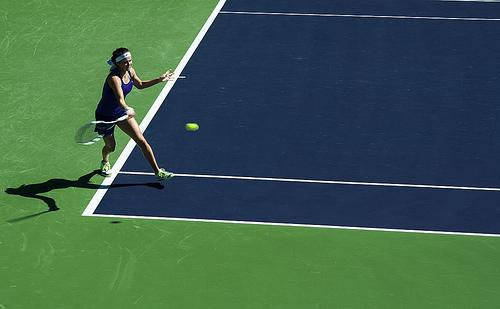In a few words, describe the main scene depicted in the image. A woman in blue tennis attire hitting a flying yellow tennis ball. Provide a basic summary of the situation shown in the image. A woman dressed in tennis gear is in motion as she prepares to hit a yellow ball during a tennis match. Explain the scene of the image in your own words. A lady wearing a blue tennis outfit is playing a game and trying to hit an airborne yellow tennis ball with her racket. Give a brief overview of the main elements in the photograph. A female athlete in blue tennis gear is swinging at a soaring yellow tennis ball in the middle of a match. In one sentence, describe what is happening in the image. The picture shows a woman tennis player in blue attire trying to strike an airborne yellow tennis ball. Write a short description of the main focus of the image. It's an image of a woman dressed in blue, playing tennis and about to hit a ball in midair. Provide a brief description of the primary action taking place in the image. A woman in a blue tennis outfit is playing a match, swinging her racket to strike a yellow tennis ball in midair. Write a concise summary of what the image depicts. The image shows a female tennis player, dressed in blue attire, attempting to hit a flying yellow ball on a tennis court. Describe the main subject of the image and their current action. A female tennis player in a blue sportswear is actively hitting a yellow ball floating in the air. Describe the primary subject and action happening in the image. A woman clad in blue tennis clothing is actively playing a match, attempting to hit a flying yellow tennis ball. 